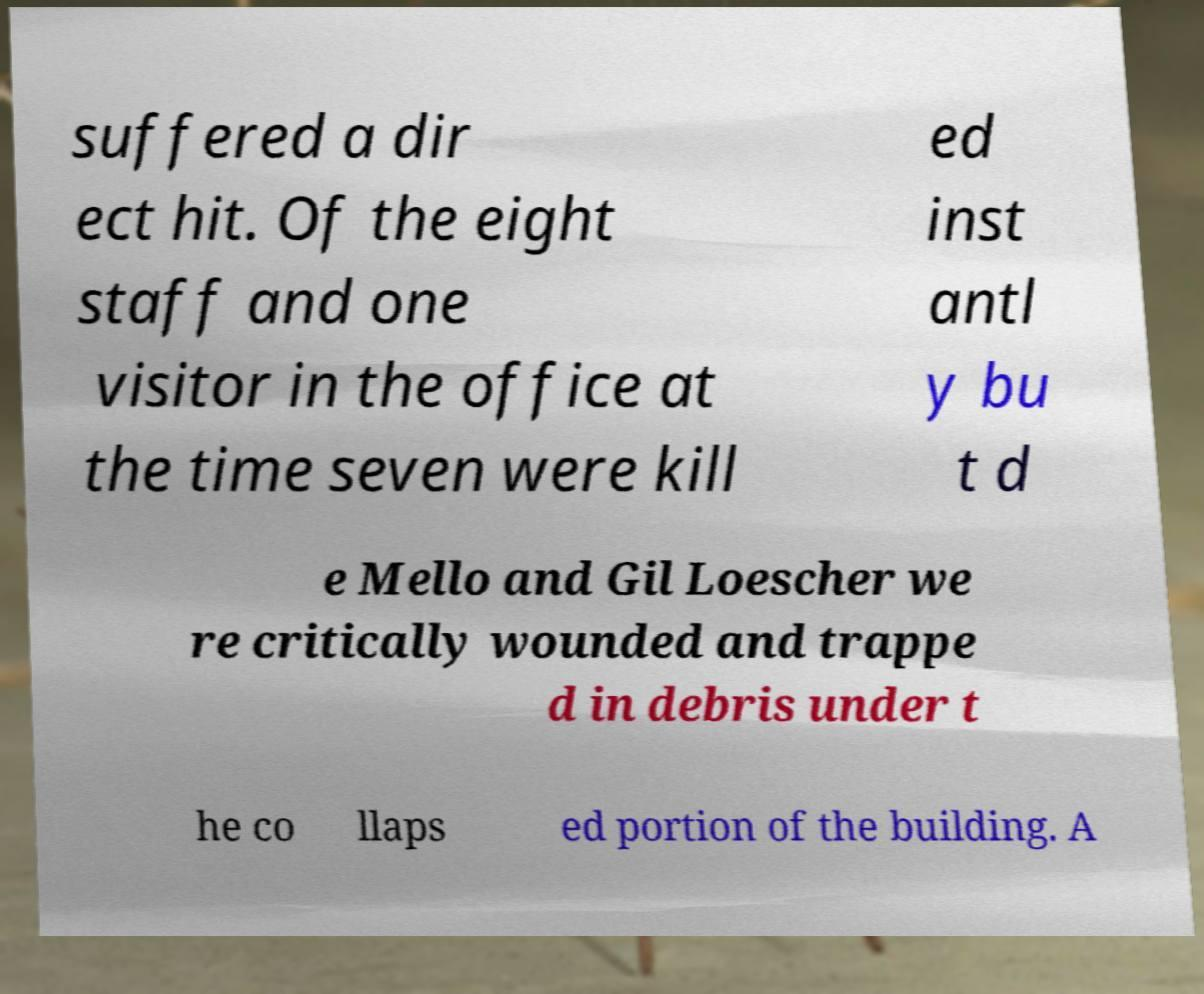Can you read and provide the text displayed in the image?This photo seems to have some interesting text. Can you extract and type it out for me? suffered a dir ect hit. Of the eight staff and one visitor in the office at the time seven were kill ed inst antl y bu t d e Mello and Gil Loescher we re critically wounded and trappe d in debris under t he co llaps ed portion of the building. A 